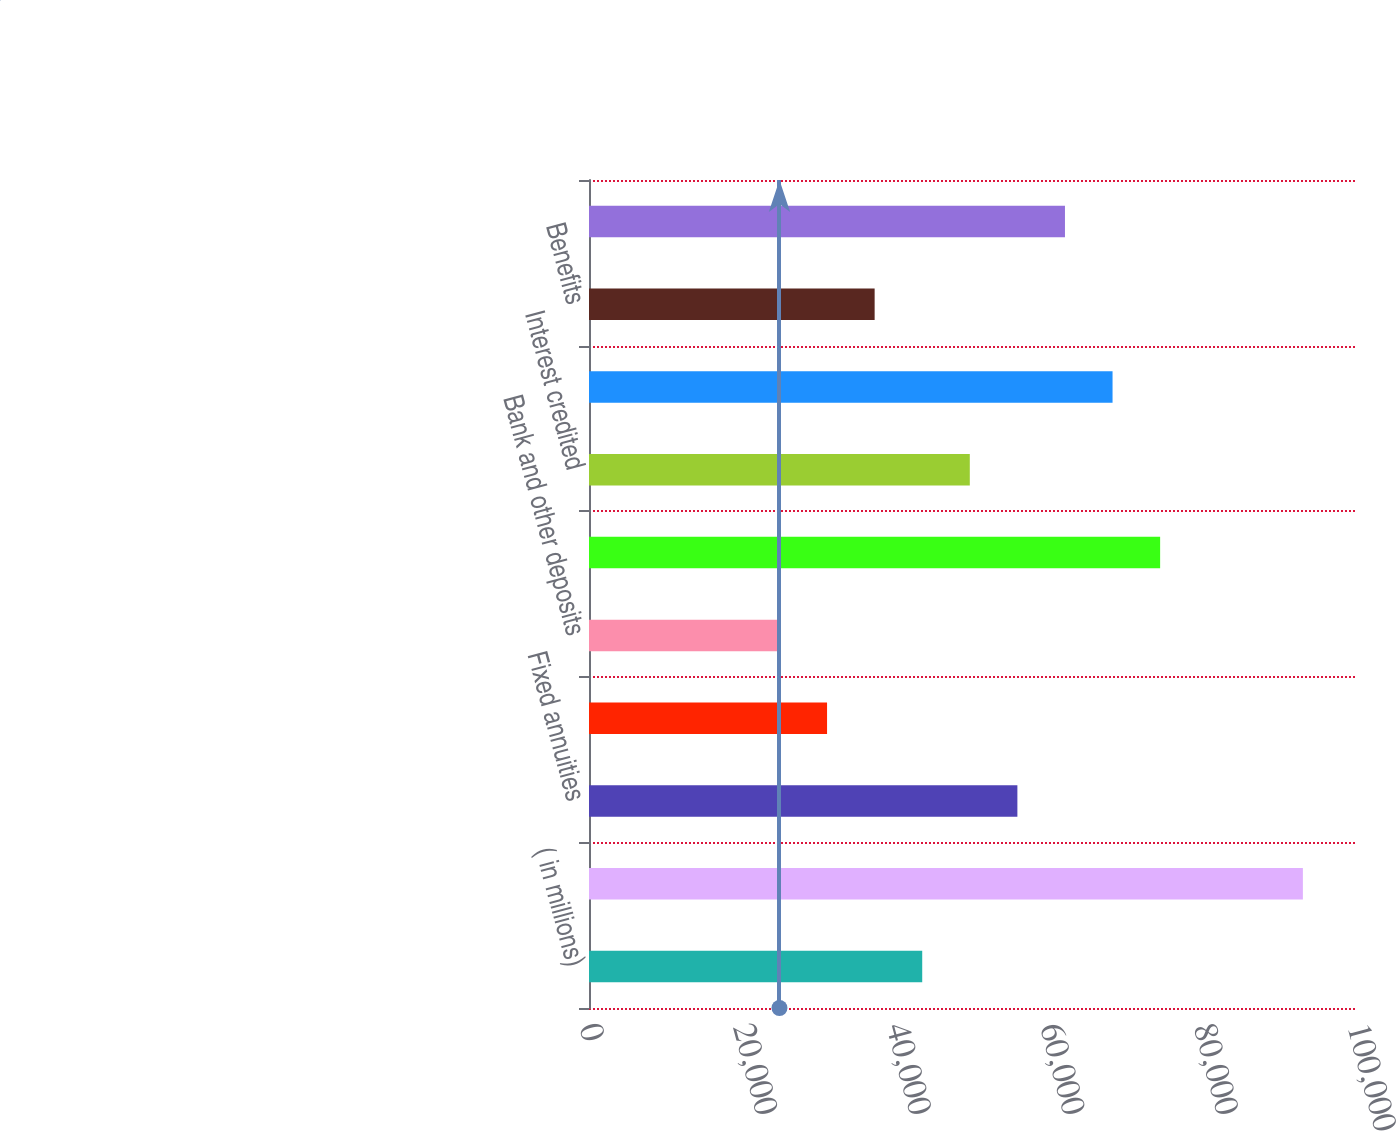Convert chart. <chart><loc_0><loc_0><loc_500><loc_500><bar_chart><fcel>( in millions)<fcel>Contractholder funds beginning<fcel>Fixed annuities<fcel>Interest-sensitive life<fcel>Bank and other deposits<fcel>Total deposits<fcel>Interest credited<fcel>Maturities and retirements of<fcel>Benefits<fcel>Surrenders and partial<nl><fcel>43388.2<fcel>92953<fcel>55779.4<fcel>30997<fcel>24801.4<fcel>74366.2<fcel>49583.8<fcel>68170.6<fcel>37192.6<fcel>61975<nl></chart> 